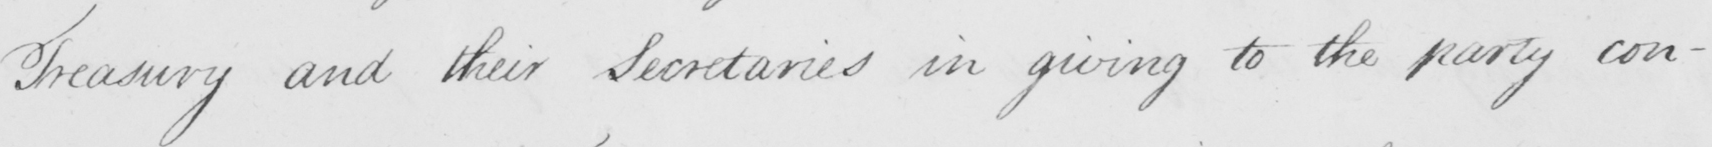Please provide the text content of this handwritten line. Treasury and their Secretaries in giving to the party con- 